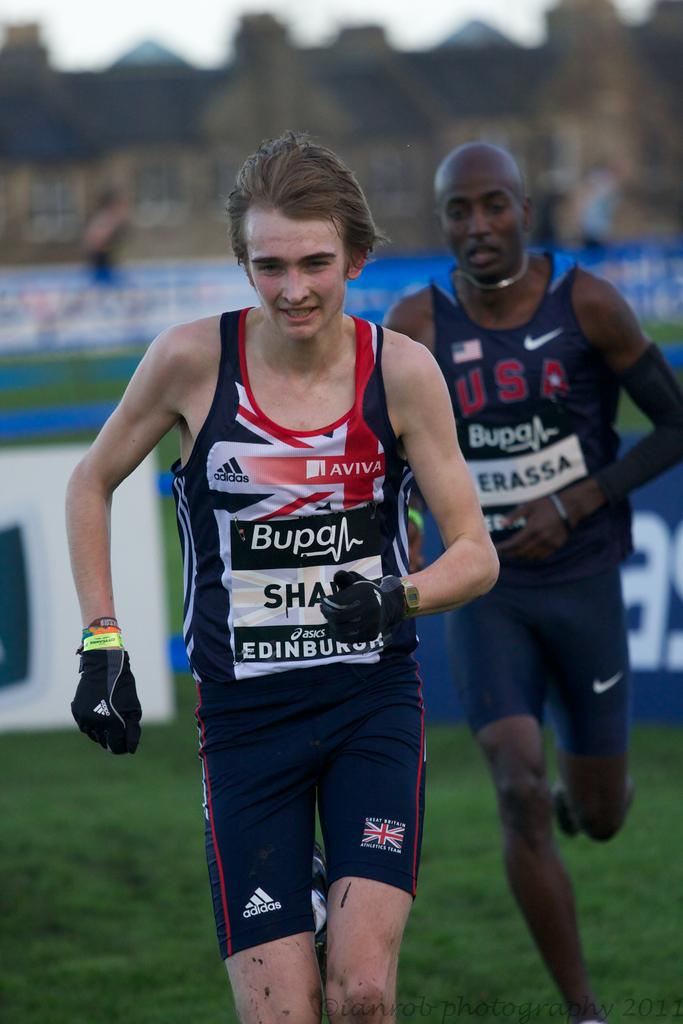<image>
Offer a succinct explanation of the picture presented. Two people running and the man from Edinburgh is in the lead. 